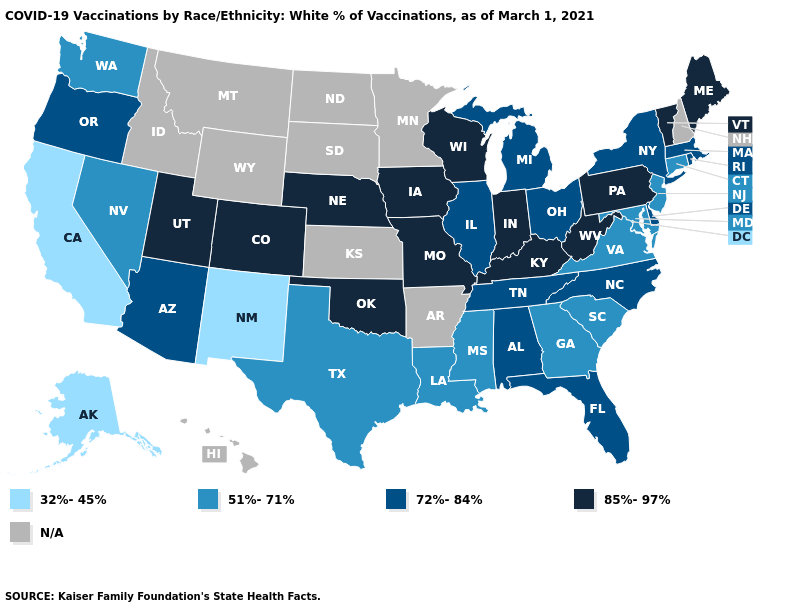How many symbols are there in the legend?
Give a very brief answer. 5. What is the value of Oklahoma?
Keep it brief. 85%-97%. Name the states that have a value in the range 32%-45%?
Write a very short answer. Alaska, California, New Mexico. Does the first symbol in the legend represent the smallest category?
Give a very brief answer. Yes. Which states have the lowest value in the West?
Write a very short answer. Alaska, California, New Mexico. What is the value of Arkansas?
Give a very brief answer. N/A. Does Rhode Island have the highest value in the USA?
Keep it brief. No. Does Rhode Island have the lowest value in the USA?
Write a very short answer. No. Which states have the lowest value in the USA?
Short answer required. Alaska, California, New Mexico. Does the first symbol in the legend represent the smallest category?
Be succinct. Yes. What is the lowest value in the USA?
Quick response, please. 32%-45%. What is the value of Arkansas?
Short answer required. N/A. Does the map have missing data?
Concise answer only. Yes. What is the highest value in the South ?
Quick response, please. 85%-97%. 